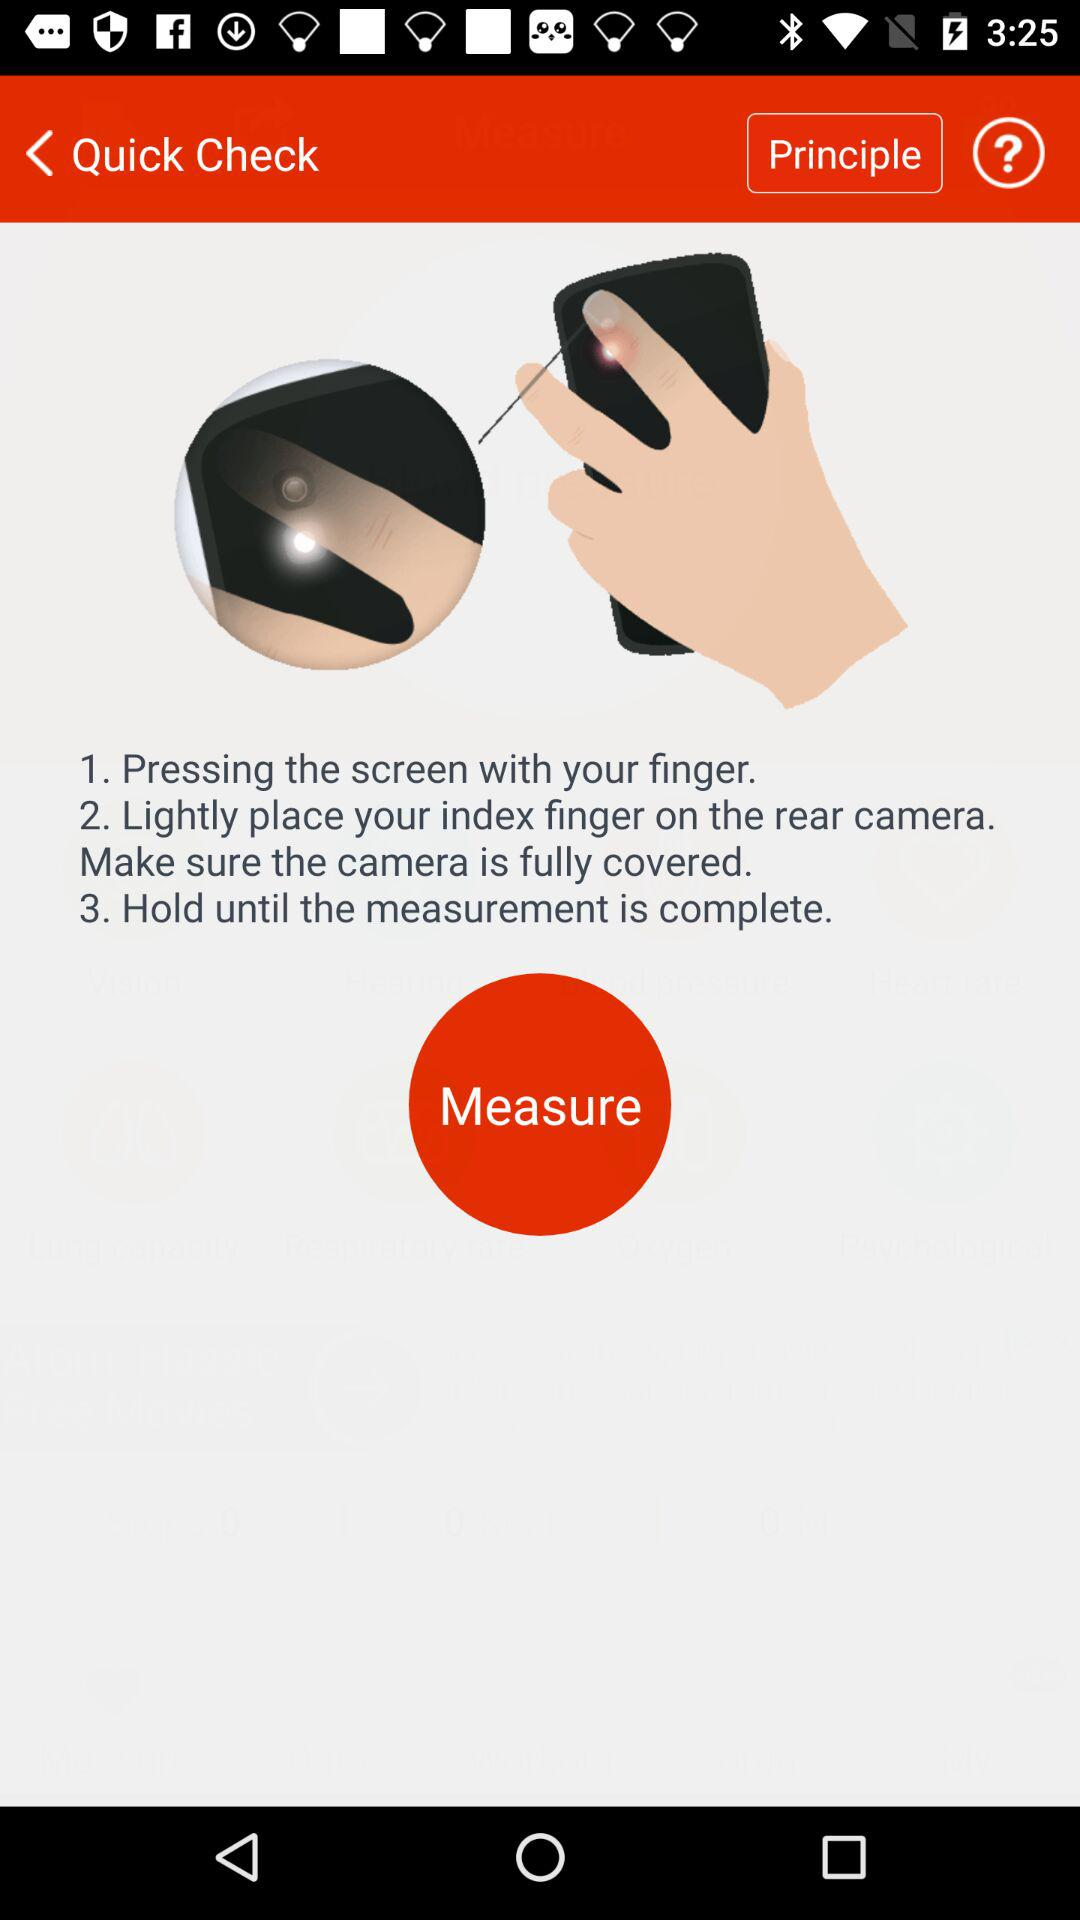How many steps are there in the instruction?
Answer the question using a single word or phrase. 3 